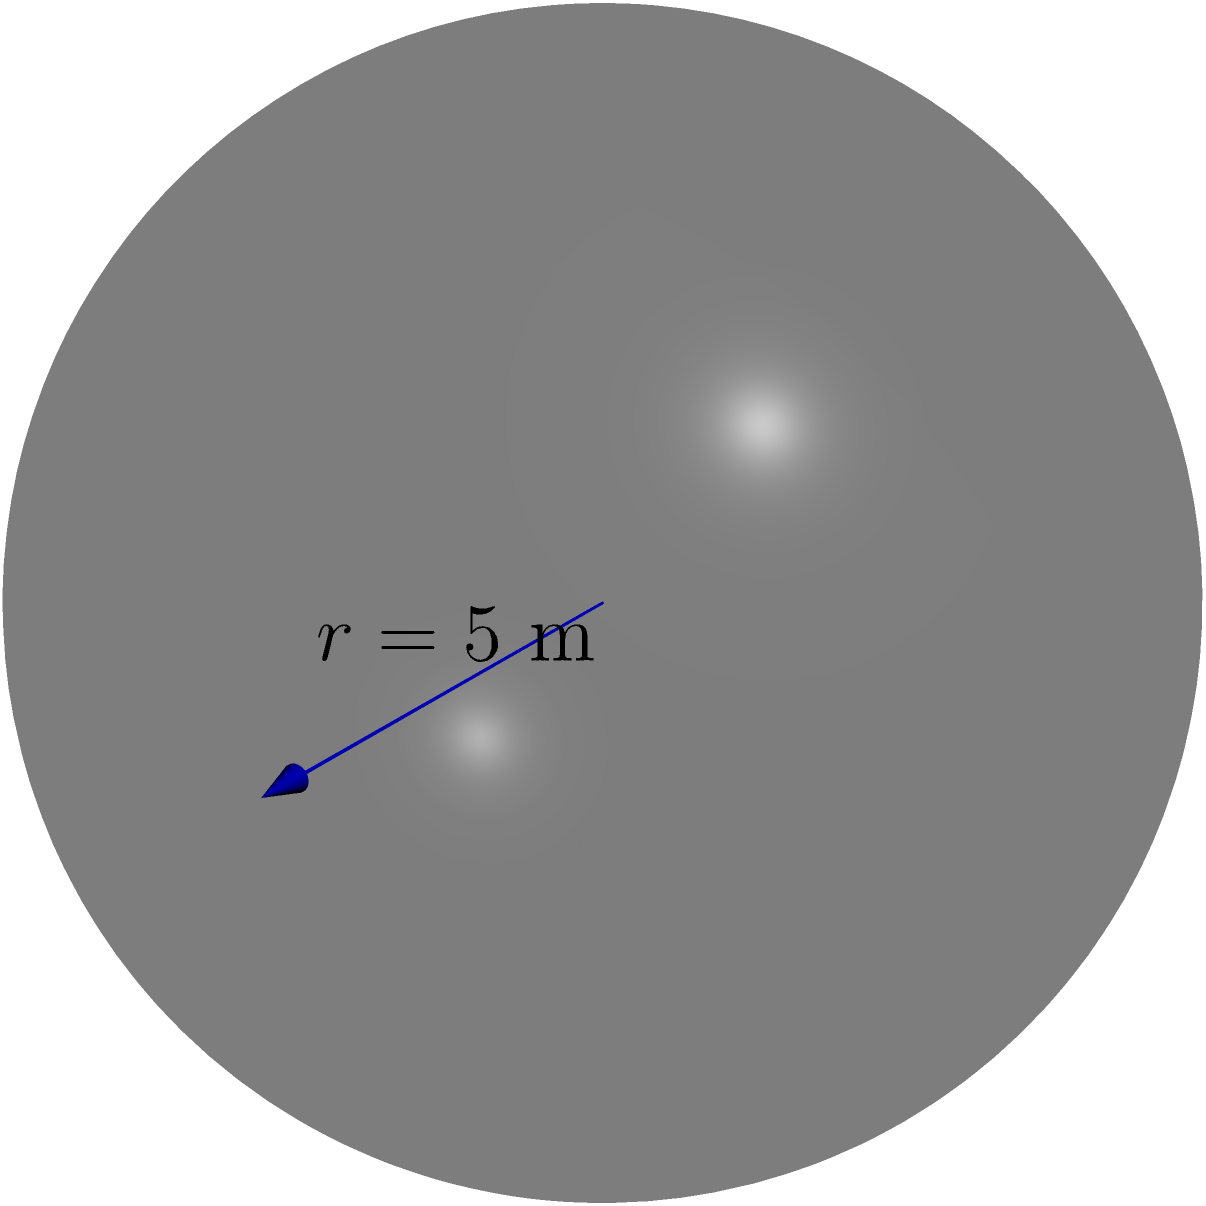As an innovative filmmaker, you're designing an immersive cinema experience using a spherical projection dome. If the radius of the dome is 5 meters, what is the volume of the space inside the dome? Round your answer to the nearest cubic meter. To solve this problem, we need to use the formula for the volume of a sphere:

$$V = \frac{4}{3}\pi r^3$$

Where:
$V$ is the volume
$r$ is the radius

Given:
$r = 5$ meters

Let's substitute the values:

$$V = \frac{4}{3}\pi (5)^3$$

Now, let's calculate step by step:

1) First, calculate $5^3$:
   $5^3 = 5 \times 5 \times 5 = 125$

2) Now our equation looks like:
   $$V = \frac{4}{3}\pi (125)$$

3) Multiply $\frac{4}{3}$ by 125:
   $$V = \frac{500}{3}\pi$$

4) Multiply by $\pi$ (use 3.14159 for $\pi$):
   $$V = \frac{500}{3} \times 3.14159 \approx 523.5983$$

5) Rounding to the nearest cubic meter:
   $V \approx 524$ cubic meters

Therefore, the volume of the spherical projection dome is approximately 524 cubic meters.
Answer: 524 cubic meters 